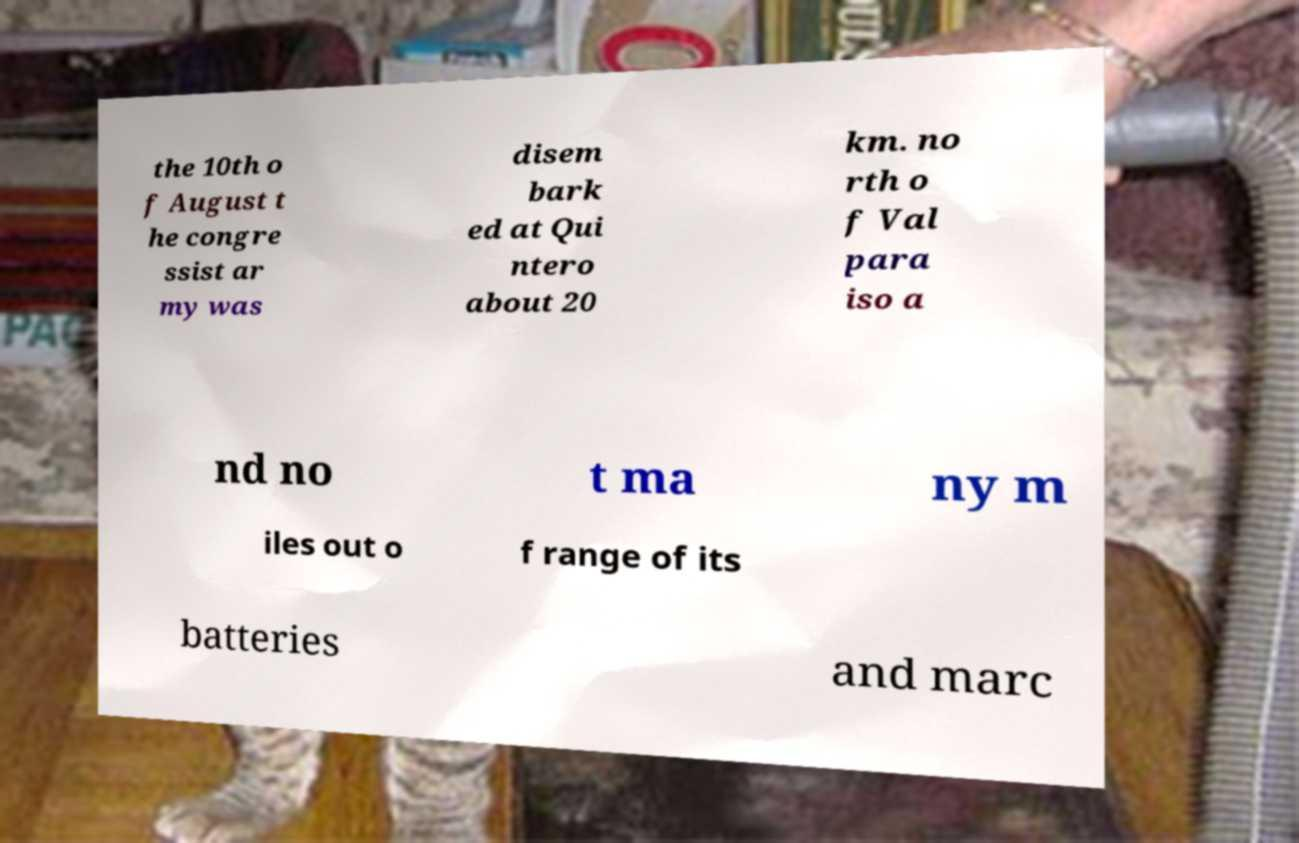Could you extract and type out the text from this image? the 10th o f August t he congre ssist ar my was disem bark ed at Qui ntero about 20 km. no rth o f Val para iso a nd no t ma ny m iles out o f range of its batteries and marc 